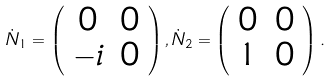Convert formula to latex. <formula><loc_0><loc_0><loc_500><loc_500>\dot { N } _ { 1 } = \left ( \begin{array} { c c } 0 & 0 \\ - i & 0 \end{array} \right ) , \dot { N } _ { 2 } = \left ( \begin{array} { c c } 0 & 0 \\ 1 & 0 \end{array} \right ) .</formula> 